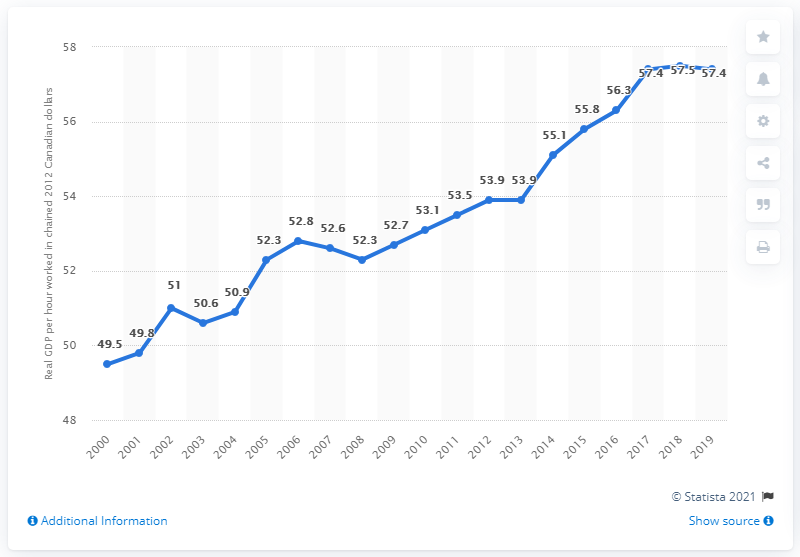List a handful of essential elements in this visual. In 2019, the labor productivity in Ontario was 57.4. 